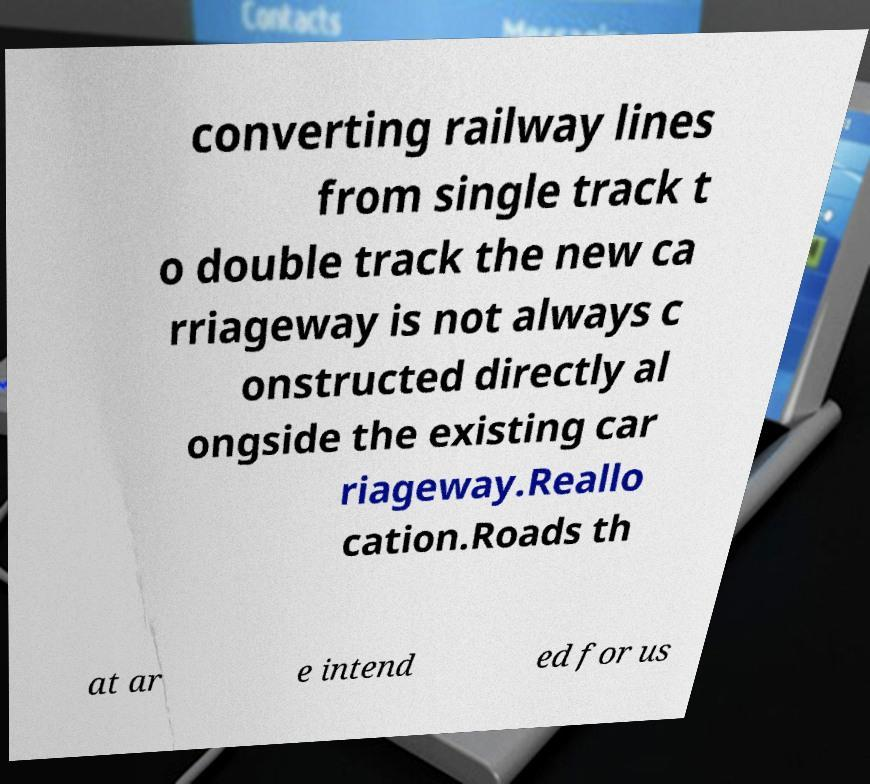Can you read and provide the text displayed in the image?This photo seems to have some interesting text. Can you extract and type it out for me? converting railway lines from single track t o double track the new ca rriageway is not always c onstructed directly al ongside the existing car riageway.Reallo cation.Roads th at ar e intend ed for us 